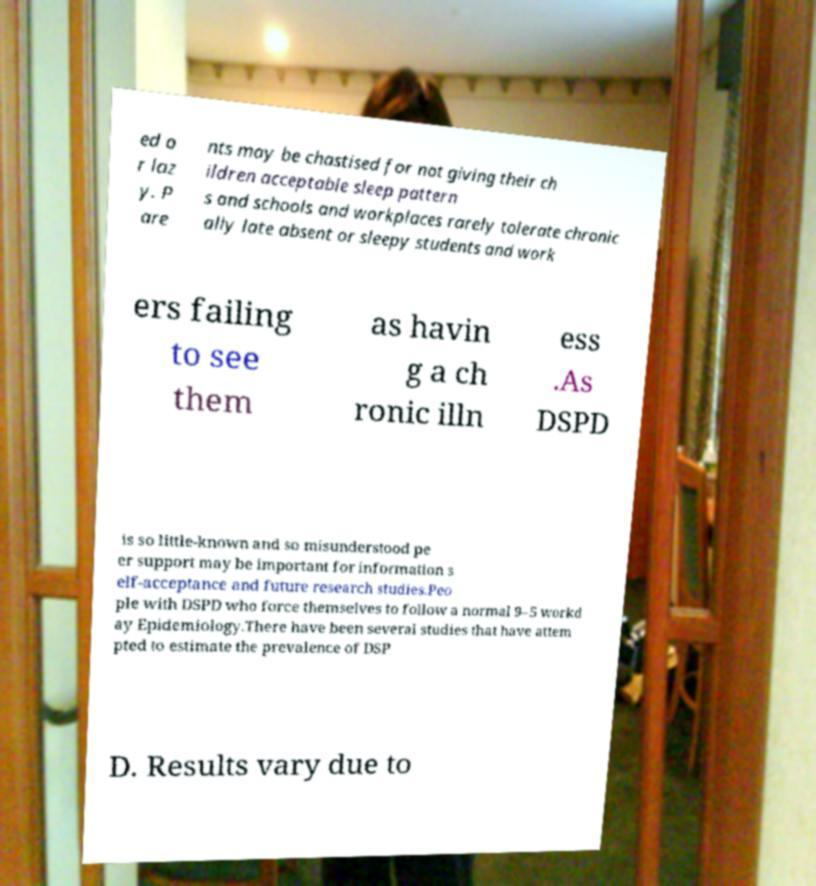Can you accurately transcribe the text from the provided image for me? ed o r laz y. P are nts may be chastised for not giving their ch ildren acceptable sleep pattern s and schools and workplaces rarely tolerate chronic ally late absent or sleepy students and work ers failing to see them as havin g a ch ronic illn ess .As DSPD is so little-known and so misunderstood pe er support may be important for information s elf-acceptance and future research studies.Peo ple with DSPD who force themselves to follow a normal 9–5 workd ay Epidemiology.There have been several studies that have attem pted to estimate the prevalence of DSP D. Results vary due to 